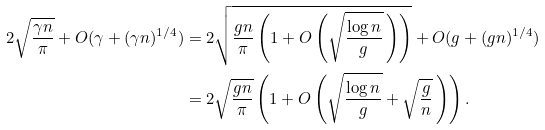Convert formula to latex. <formula><loc_0><loc_0><loc_500><loc_500>2 \sqrt { \frac { \gamma n } \pi } + O ( \gamma + ( \gamma n ) ^ { 1 / 4 } ) & = 2 \sqrt { \frac { g n } \pi \left ( 1 + O \left ( \sqrt { \frac { \log n } g } \, \right ) \right ) } + O ( g + ( g n ) ^ { 1 / 4 } ) \\ & = 2 \sqrt { \frac { g n } \pi } \left ( 1 + O \left ( \sqrt { \frac { \log n } g } + \sqrt { \frac { g } { n } } \, \right ) \right ) .</formula> 